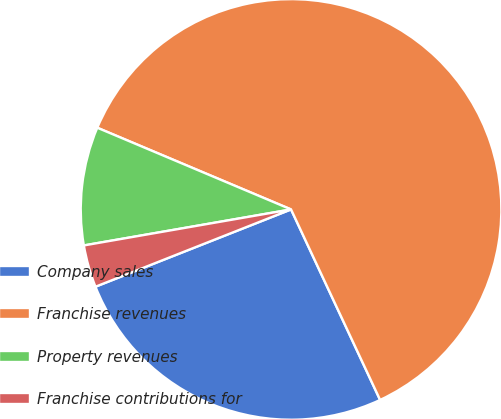Convert chart to OTSL. <chart><loc_0><loc_0><loc_500><loc_500><pie_chart><fcel>Company sales<fcel>Franchise revenues<fcel>Property revenues<fcel>Franchise contributions for<nl><fcel>25.97%<fcel>61.69%<fcel>9.09%<fcel>3.25%<nl></chart> 